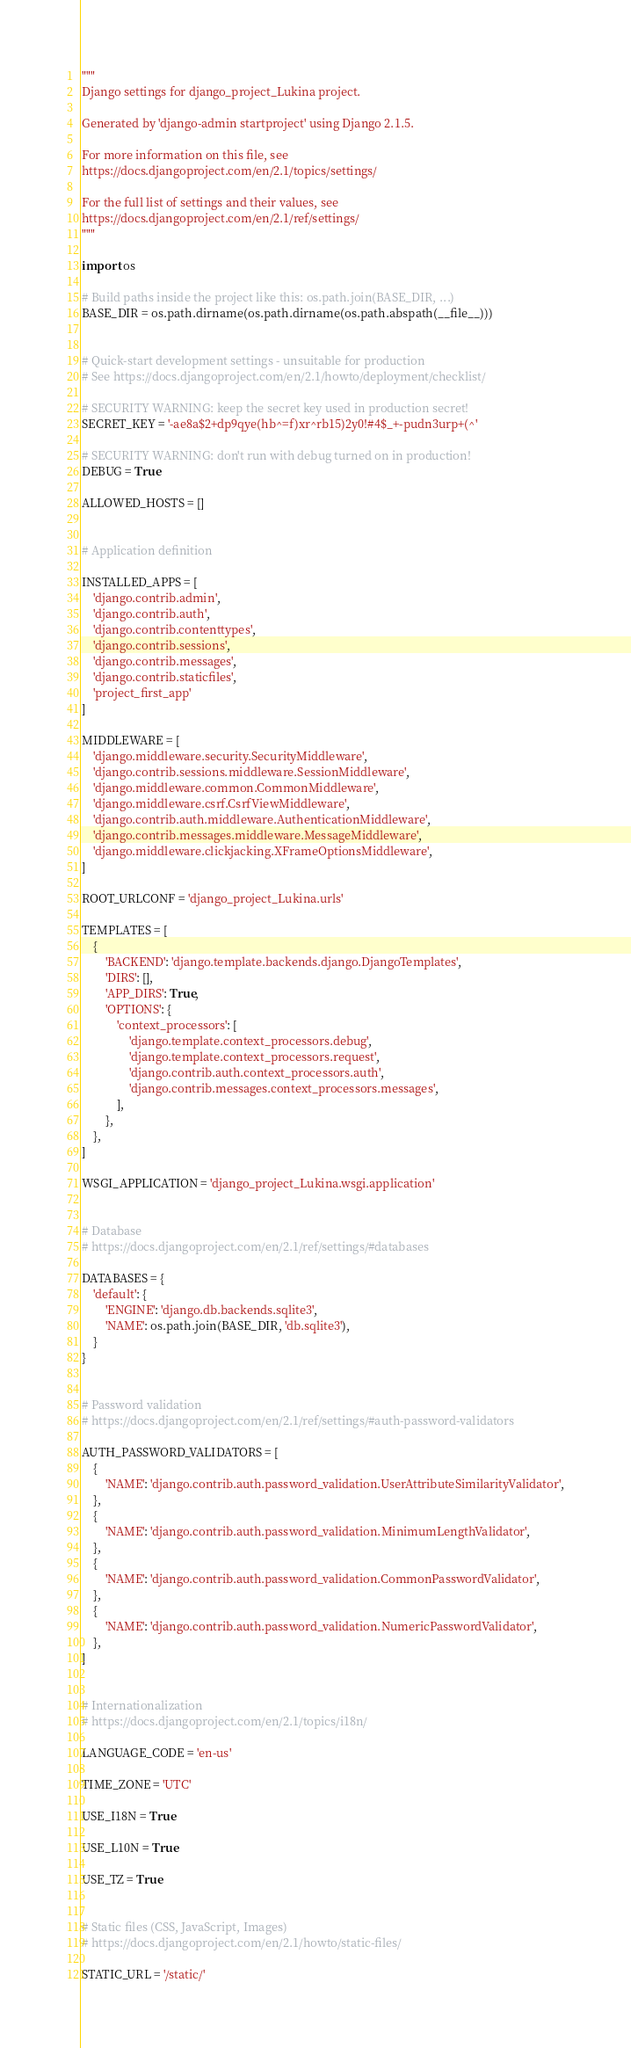Convert code to text. <code><loc_0><loc_0><loc_500><loc_500><_Python_>"""
Django settings for django_project_Lukina project.

Generated by 'django-admin startproject' using Django 2.1.5.

For more information on this file, see
https://docs.djangoproject.com/en/2.1/topics/settings/

For the full list of settings and their values, see
https://docs.djangoproject.com/en/2.1/ref/settings/
"""

import os

# Build paths inside the project like this: os.path.join(BASE_DIR, ...)
BASE_DIR = os.path.dirname(os.path.dirname(os.path.abspath(__file__)))


# Quick-start development settings - unsuitable for production
# See https://docs.djangoproject.com/en/2.1/howto/deployment/checklist/

# SECURITY WARNING: keep the secret key used in production secret!
SECRET_KEY = '-ae8a$2+dp9qye(hb^=f)xr^rb15)2y0!#4$_+-pudn3urp+(^'

# SECURITY WARNING: don't run with debug turned on in production!
DEBUG = True

ALLOWED_HOSTS = []


# Application definition

INSTALLED_APPS = [
    'django.contrib.admin',
    'django.contrib.auth',
    'django.contrib.contenttypes',
    'django.contrib.sessions',
    'django.contrib.messages',
    'django.contrib.staticfiles',
    'project_first_app'
]

MIDDLEWARE = [
    'django.middleware.security.SecurityMiddleware',
    'django.contrib.sessions.middleware.SessionMiddleware',
    'django.middleware.common.CommonMiddleware',
    'django.middleware.csrf.CsrfViewMiddleware',
    'django.contrib.auth.middleware.AuthenticationMiddleware',
    'django.contrib.messages.middleware.MessageMiddleware',
    'django.middleware.clickjacking.XFrameOptionsMiddleware',
]

ROOT_URLCONF = 'django_project_Lukina.urls'

TEMPLATES = [
    {
        'BACKEND': 'django.template.backends.django.DjangoTemplates',
        'DIRS': [],
        'APP_DIRS': True,
        'OPTIONS': {
            'context_processors': [
                'django.template.context_processors.debug',
                'django.template.context_processors.request',
                'django.contrib.auth.context_processors.auth',
                'django.contrib.messages.context_processors.messages',
            ],
        },
    },
]

WSGI_APPLICATION = 'django_project_Lukina.wsgi.application'


# Database
# https://docs.djangoproject.com/en/2.1/ref/settings/#databases

DATABASES = {
    'default': {
        'ENGINE': 'django.db.backends.sqlite3',
        'NAME': os.path.join(BASE_DIR, 'db.sqlite3'),
    }
}


# Password validation
# https://docs.djangoproject.com/en/2.1/ref/settings/#auth-password-validators

AUTH_PASSWORD_VALIDATORS = [
    {
        'NAME': 'django.contrib.auth.password_validation.UserAttributeSimilarityValidator',
    },
    {
        'NAME': 'django.contrib.auth.password_validation.MinimumLengthValidator',
    },
    {
        'NAME': 'django.contrib.auth.password_validation.CommonPasswordValidator',
    },
    {
        'NAME': 'django.contrib.auth.password_validation.NumericPasswordValidator',
    },
]


# Internationalization
# https://docs.djangoproject.com/en/2.1/topics/i18n/

LANGUAGE_CODE = 'en-us'

TIME_ZONE = 'UTC'

USE_I18N = True

USE_L10N = True

USE_TZ = True


# Static files (CSS, JavaScript, Images)
# https://docs.djangoproject.com/en/2.1/howto/static-files/

STATIC_URL = '/static/'
</code> 